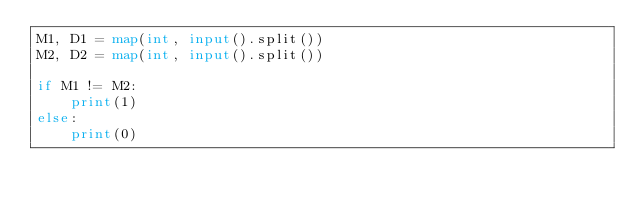Convert code to text. <code><loc_0><loc_0><loc_500><loc_500><_Python_>M1, D1 = map(int, input().split())
M2, D2 = map(int, input().split())

if M1 != M2:
    print(1)
else:
    print(0)
</code> 